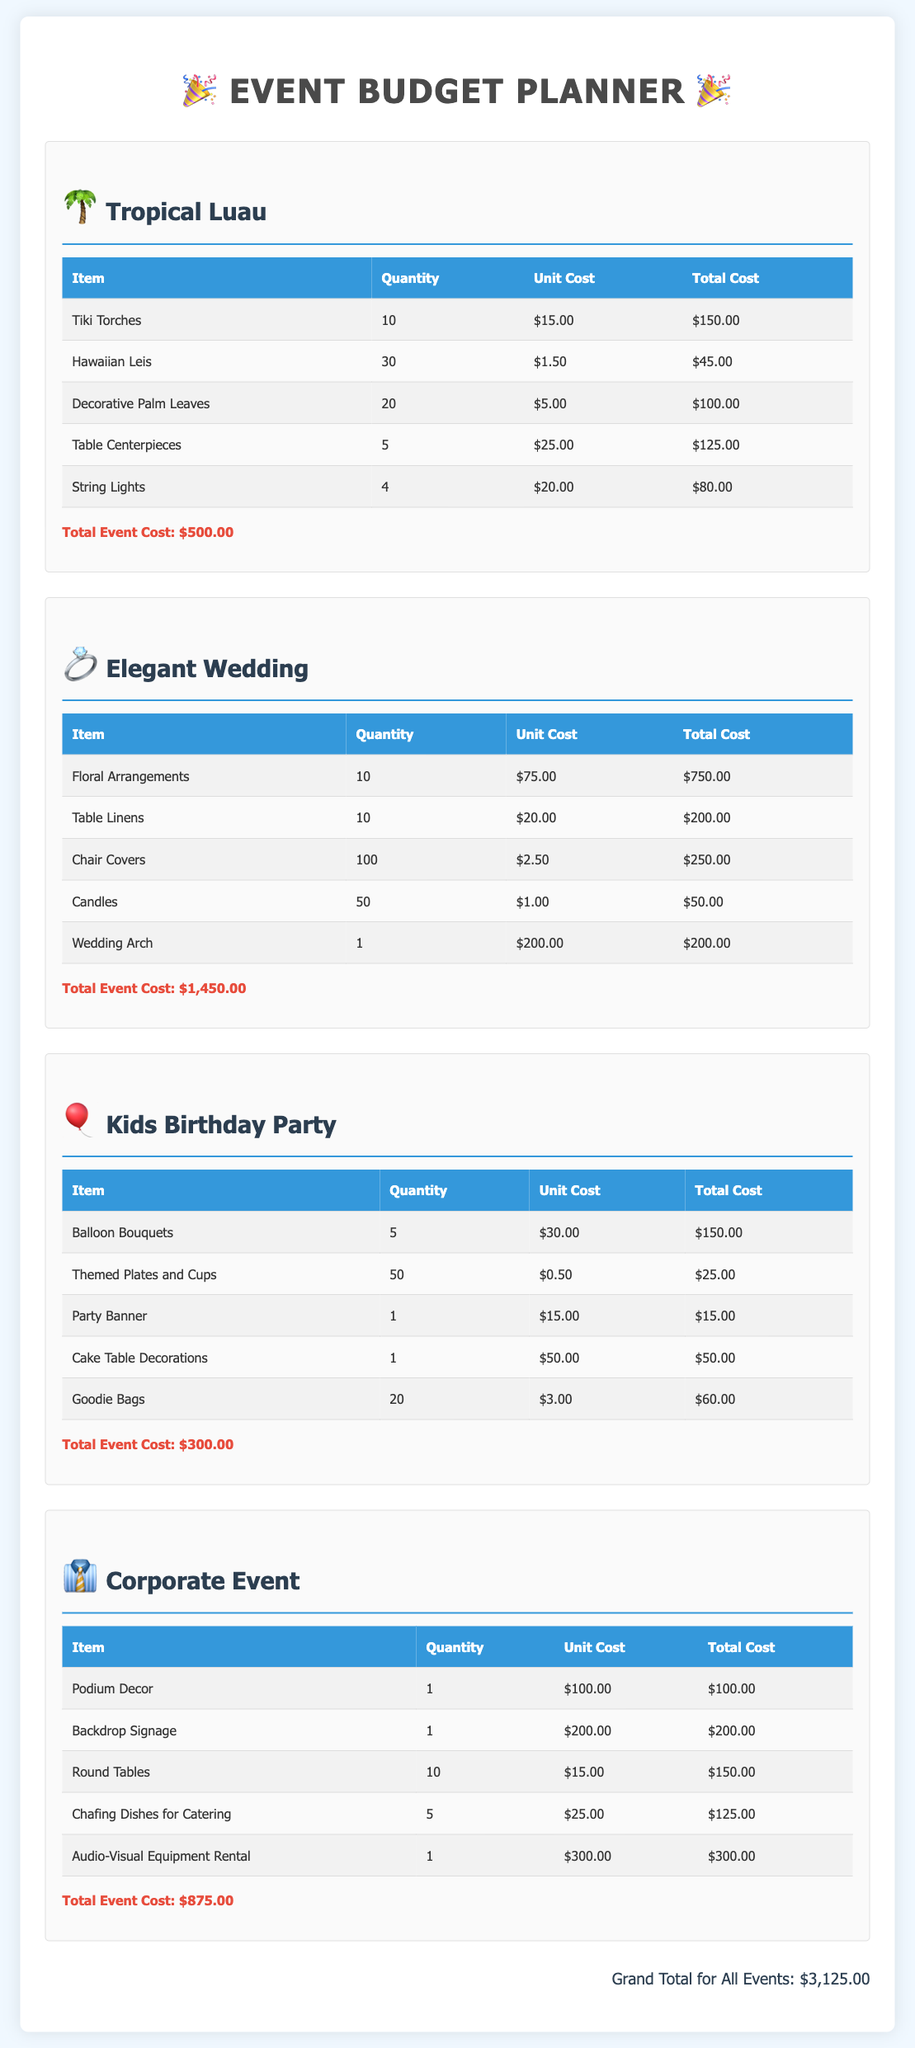What is the total cost for the Tropical Luau? The total cost for the Tropical Luau is listed in the document as $500.00.
Answer: $500.00 How many Chair Covers are needed for the Elegant Wedding? The document specifies that 100 Chair Covers are needed for the Elegant Wedding.
Answer: 100 What is the unit cost of String Lights in the Tropical Luau section? The unit cost of String Lights is mentioned as $20.00 in the Tropical Luau section.
Answer: $20.00 Which event has the highest total budget? By comparing the total costs of all events in the document, the Elegant Wedding has the highest total budget at $1,450.00.
Answer: Elegant Wedding What is the quantity of Goodie Bags for the Kids Birthday Party? The document states that 20 Goodie Bags are required for the Kids Birthday Party.
Answer: 20 How much does the Audio-Visual Equipment Rental cost for the Corporate Event? The cost for Audio-Visual Equipment Rental for the Corporate Event is $300.00 as per the document.
Answer: $300.00 What is the grand total for all events? The grand total for all events is summarized in the document as $3,125.00.
Answer: $3,125.00 Which item has the highest unit cost in the Elegant Wedding section? The item with the highest unit cost in the Elegant Wedding section is Floral Arrangements at $75.00.
Answer: Floral Arrangements How many Table Centerpieces are needed for the Tropical Luau? The document indicates that 5 Table Centerpieces are needed for the Tropical Luau.
Answer: 5 